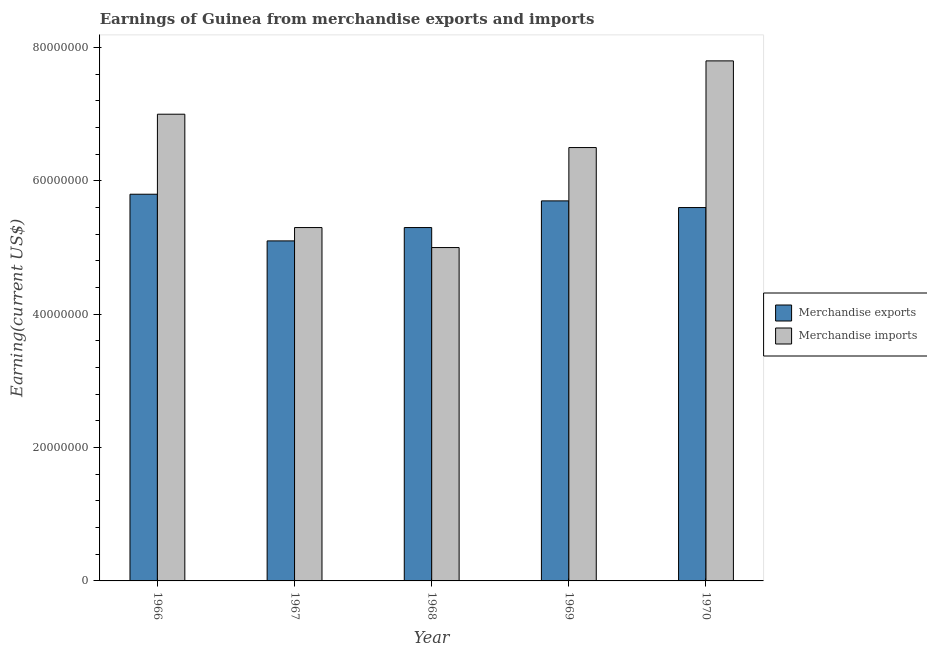How many different coloured bars are there?
Keep it short and to the point. 2. Are the number of bars on each tick of the X-axis equal?
Your answer should be very brief. Yes. How many bars are there on the 1st tick from the left?
Offer a very short reply. 2. How many bars are there on the 3rd tick from the right?
Your answer should be very brief. 2. What is the label of the 4th group of bars from the left?
Provide a short and direct response. 1969. What is the earnings from merchandise imports in 1969?
Make the answer very short. 6.50e+07. Across all years, what is the maximum earnings from merchandise exports?
Your response must be concise. 5.80e+07. Across all years, what is the minimum earnings from merchandise exports?
Provide a short and direct response. 5.10e+07. In which year was the earnings from merchandise imports maximum?
Your answer should be very brief. 1970. In which year was the earnings from merchandise imports minimum?
Your response must be concise. 1968. What is the total earnings from merchandise exports in the graph?
Keep it short and to the point. 2.75e+08. What is the difference between the earnings from merchandise imports in 1966 and that in 1967?
Provide a short and direct response. 1.70e+07. What is the average earnings from merchandise imports per year?
Your answer should be very brief. 6.32e+07. In the year 1968, what is the difference between the earnings from merchandise imports and earnings from merchandise exports?
Provide a short and direct response. 0. In how many years, is the earnings from merchandise imports greater than 72000000 US$?
Ensure brevity in your answer.  1. What is the ratio of the earnings from merchandise imports in 1967 to that in 1969?
Make the answer very short. 0.82. Is the earnings from merchandise imports in 1966 less than that in 1967?
Your answer should be very brief. No. Is the difference between the earnings from merchandise exports in 1966 and 1968 greater than the difference between the earnings from merchandise imports in 1966 and 1968?
Keep it short and to the point. No. What is the difference between the highest and the second highest earnings from merchandise exports?
Offer a terse response. 1.00e+06. What is the difference between the highest and the lowest earnings from merchandise imports?
Your answer should be very brief. 2.80e+07. In how many years, is the earnings from merchandise exports greater than the average earnings from merchandise exports taken over all years?
Your answer should be very brief. 3. Is the sum of the earnings from merchandise exports in 1967 and 1970 greater than the maximum earnings from merchandise imports across all years?
Provide a succinct answer. Yes. What does the 2nd bar from the left in 1970 represents?
Offer a terse response. Merchandise imports. What does the 1st bar from the right in 1966 represents?
Offer a terse response. Merchandise imports. How many bars are there?
Your response must be concise. 10. How many years are there in the graph?
Your answer should be very brief. 5. Are the values on the major ticks of Y-axis written in scientific E-notation?
Your answer should be compact. No. Where does the legend appear in the graph?
Your answer should be very brief. Center right. How many legend labels are there?
Keep it short and to the point. 2. What is the title of the graph?
Your response must be concise. Earnings of Guinea from merchandise exports and imports. What is the label or title of the X-axis?
Make the answer very short. Year. What is the label or title of the Y-axis?
Provide a succinct answer. Earning(current US$). What is the Earning(current US$) in Merchandise exports in 1966?
Your response must be concise. 5.80e+07. What is the Earning(current US$) of Merchandise imports in 1966?
Offer a very short reply. 7.00e+07. What is the Earning(current US$) of Merchandise exports in 1967?
Provide a succinct answer. 5.10e+07. What is the Earning(current US$) in Merchandise imports in 1967?
Ensure brevity in your answer.  5.30e+07. What is the Earning(current US$) of Merchandise exports in 1968?
Provide a succinct answer. 5.30e+07. What is the Earning(current US$) in Merchandise imports in 1968?
Keep it short and to the point. 5.00e+07. What is the Earning(current US$) in Merchandise exports in 1969?
Your response must be concise. 5.70e+07. What is the Earning(current US$) of Merchandise imports in 1969?
Your answer should be very brief. 6.50e+07. What is the Earning(current US$) in Merchandise exports in 1970?
Offer a very short reply. 5.60e+07. What is the Earning(current US$) in Merchandise imports in 1970?
Keep it short and to the point. 7.80e+07. Across all years, what is the maximum Earning(current US$) of Merchandise exports?
Give a very brief answer. 5.80e+07. Across all years, what is the maximum Earning(current US$) in Merchandise imports?
Provide a short and direct response. 7.80e+07. Across all years, what is the minimum Earning(current US$) of Merchandise exports?
Your answer should be very brief. 5.10e+07. What is the total Earning(current US$) of Merchandise exports in the graph?
Your response must be concise. 2.75e+08. What is the total Earning(current US$) in Merchandise imports in the graph?
Give a very brief answer. 3.16e+08. What is the difference between the Earning(current US$) of Merchandise imports in 1966 and that in 1967?
Keep it short and to the point. 1.70e+07. What is the difference between the Earning(current US$) in Merchandise imports in 1966 and that in 1969?
Your answer should be compact. 5.00e+06. What is the difference between the Earning(current US$) of Merchandise imports in 1966 and that in 1970?
Your answer should be very brief. -8.00e+06. What is the difference between the Earning(current US$) in Merchandise exports in 1967 and that in 1968?
Offer a terse response. -2.00e+06. What is the difference between the Earning(current US$) in Merchandise imports in 1967 and that in 1968?
Your answer should be compact. 3.00e+06. What is the difference between the Earning(current US$) of Merchandise exports in 1967 and that in 1969?
Provide a succinct answer. -6.00e+06. What is the difference between the Earning(current US$) of Merchandise imports in 1967 and that in 1969?
Ensure brevity in your answer.  -1.20e+07. What is the difference between the Earning(current US$) of Merchandise exports in 1967 and that in 1970?
Ensure brevity in your answer.  -5.00e+06. What is the difference between the Earning(current US$) of Merchandise imports in 1967 and that in 1970?
Make the answer very short. -2.50e+07. What is the difference between the Earning(current US$) in Merchandise imports in 1968 and that in 1969?
Your response must be concise. -1.50e+07. What is the difference between the Earning(current US$) in Merchandise exports in 1968 and that in 1970?
Offer a terse response. -3.00e+06. What is the difference between the Earning(current US$) of Merchandise imports in 1968 and that in 1970?
Your response must be concise. -2.80e+07. What is the difference between the Earning(current US$) of Merchandise imports in 1969 and that in 1970?
Make the answer very short. -1.30e+07. What is the difference between the Earning(current US$) in Merchandise exports in 1966 and the Earning(current US$) in Merchandise imports in 1967?
Your answer should be compact. 5.00e+06. What is the difference between the Earning(current US$) in Merchandise exports in 1966 and the Earning(current US$) in Merchandise imports in 1969?
Provide a succinct answer. -7.00e+06. What is the difference between the Earning(current US$) in Merchandise exports in 1966 and the Earning(current US$) in Merchandise imports in 1970?
Offer a terse response. -2.00e+07. What is the difference between the Earning(current US$) of Merchandise exports in 1967 and the Earning(current US$) of Merchandise imports in 1969?
Keep it short and to the point. -1.40e+07. What is the difference between the Earning(current US$) of Merchandise exports in 1967 and the Earning(current US$) of Merchandise imports in 1970?
Make the answer very short. -2.70e+07. What is the difference between the Earning(current US$) of Merchandise exports in 1968 and the Earning(current US$) of Merchandise imports in 1969?
Your answer should be compact. -1.20e+07. What is the difference between the Earning(current US$) in Merchandise exports in 1968 and the Earning(current US$) in Merchandise imports in 1970?
Your response must be concise. -2.50e+07. What is the difference between the Earning(current US$) in Merchandise exports in 1969 and the Earning(current US$) in Merchandise imports in 1970?
Offer a very short reply. -2.10e+07. What is the average Earning(current US$) of Merchandise exports per year?
Ensure brevity in your answer.  5.50e+07. What is the average Earning(current US$) of Merchandise imports per year?
Ensure brevity in your answer.  6.32e+07. In the year 1966, what is the difference between the Earning(current US$) of Merchandise exports and Earning(current US$) of Merchandise imports?
Make the answer very short. -1.20e+07. In the year 1968, what is the difference between the Earning(current US$) of Merchandise exports and Earning(current US$) of Merchandise imports?
Make the answer very short. 3.00e+06. In the year 1969, what is the difference between the Earning(current US$) of Merchandise exports and Earning(current US$) of Merchandise imports?
Provide a succinct answer. -8.00e+06. In the year 1970, what is the difference between the Earning(current US$) of Merchandise exports and Earning(current US$) of Merchandise imports?
Provide a short and direct response. -2.20e+07. What is the ratio of the Earning(current US$) of Merchandise exports in 1966 to that in 1967?
Make the answer very short. 1.14. What is the ratio of the Earning(current US$) of Merchandise imports in 1966 to that in 1967?
Your response must be concise. 1.32. What is the ratio of the Earning(current US$) of Merchandise exports in 1966 to that in 1968?
Ensure brevity in your answer.  1.09. What is the ratio of the Earning(current US$) in Merchandise exports in 1966 to that in 1969?
Offer a very short reply. 1.02. What is the ratio of the Earning(current US$) in Merchandise exports in 1966 to that in 1970?
Offer a terse response. 1.04. What is the ratio of the Earning(current US$) of Merchandise imports in 1966 to that in 1970?
Your answer should be compact. 0.9. What is the ratio of the Earning(current US$) of Merchandise exports in 1967 to that in 1968?
Provide a succinct answer. 0.96. What is the ratio of the Earning(current US$) in Merchandise imports in 1967 to that in 1968?
Your answer should be very brief. 1.06. What is the ratio of the Earning(current US$) of Merchandise exports in 1967 to that in 1969?
Keep it short and to the point. 0.89. What is the ratio of the Earning(current US$) of Merchandise imports in 1967 to that in 1969?
Offer a terse response. 0.82. What is the ratio of the Earning(current US$) in Merchandise exports in 1967 to that in 1970?
Your response must be concise. 0.91. What is the ratio of the Earning(current US$) of Merchandise imports in 1967 to that in 1970?
Provide a succinct answer. 0.68. What is the ratio of the Earning(current US$) of Merchandise exports in 1968 to that in 1969?
Your answer should be compact. 0.93. What is the ratio of the Earning(current US$) of Merchandise imports in 1968 to that in 1969?
Your answer should be very brief. 0.77. What is the ratio of the Earning(current US$) of Merchandise exports in 1968 to that in 1970?
Offer a terse response. 0.95. What is the ratio of the Earning(current US$) of Merchandise imports in 1968 to that in 1970?
Provide a short and direct response. 0.64. What is the ratio of the Earning(current US$) of Merchandise exports in 1969 to that in 1970?
Your response must be concise. 1.02. What is the ratio of the Earning(current US$) in Merchandise imports in 1969 to that in 1970?
Keep it short and to the point. 0.83. What is the difference between the highest and the second highest Earning(current US$) of Merchandise exports?
Give a very brief answer. 1.00e+06. What is the difference between the highest and the lowest Earning(current US$) of Merchandise imports?
Ensure brevity in your answer.  2.80e+07. 